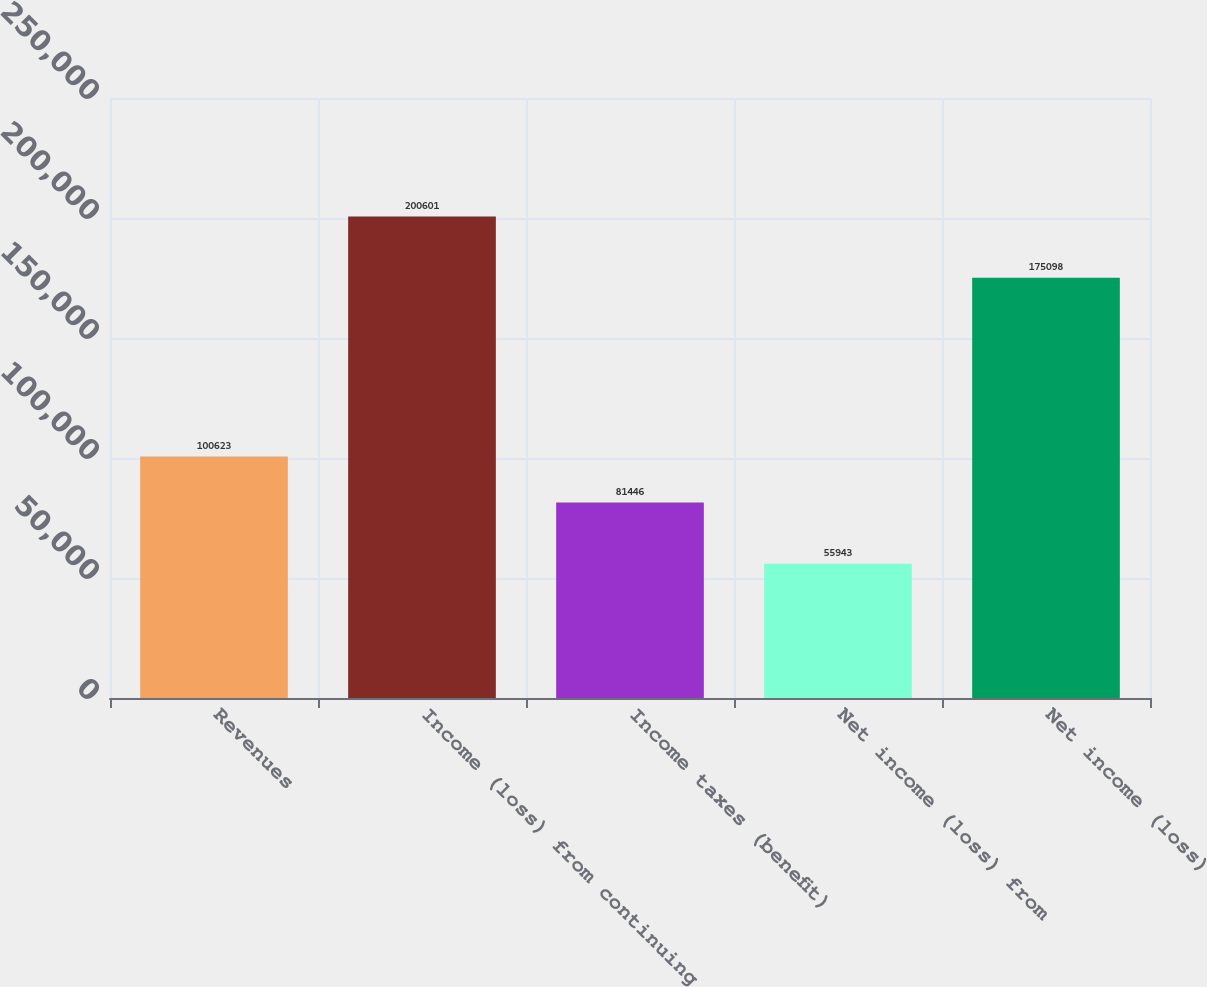<chart> <loc_0><loc_0><loc_500><loc_500><bar_chart><fcel>Revenues<fcel>Income (loss) from continuing<fcel>Income taxes (benefit)<fcel>Net income (loss) from<fcel>Net income (loss)<nl><fcel>100623<fcel>200601<fcel>81446<fcel>55943<fcel>175098<nl></chart> 